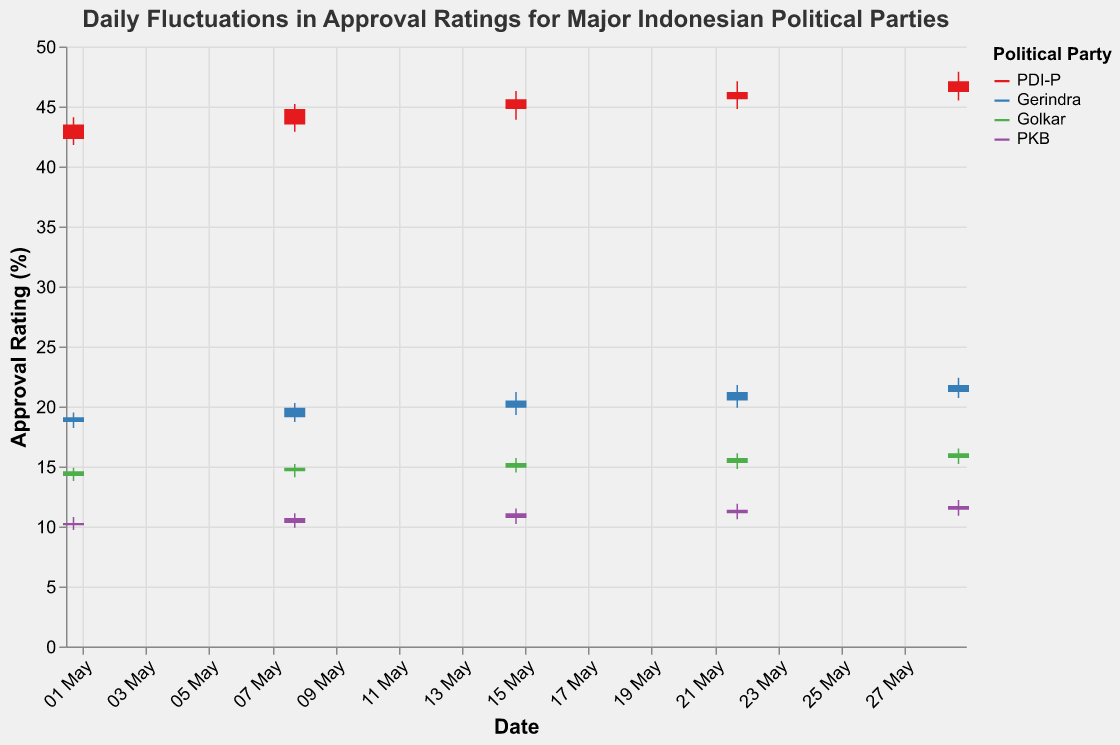What is the overall trend in the approval rating for PDI-P throughout May? The approval rating for PDI-P shows a consistent upward trend throughout May. Starting at 43.5% on May 1st, it increases weekly, ending at 47.1% on May 29th.
Answer: Upward trend How many political parties are represented in the chart? There are four political parties represented in the chart: PDI-P, Gerindra, Golkar, and PKB.
Answer: Four Which party had the highest approval rating on May 22nd? On May 22nd, PDI-P had the highest approval rating with a closing value of 46.2%.
Answer: PDI-P What was the lowest recorded approval rating for PKB in May? The lowest recorded approval rating for PKB in May was 9.7% on May 1st.
Answer: 9.7% Did any party experience a decrease in their approval rating from May 1st to May 29th? No, all parties experienced increases in their approval ratings from May 1st to May 29th.
Answer: No What is the difference between the highest and lowest approval ratings for Gerindra on May 29th? Gerindra's highest rating on May 29th was 22.4%, and the lowest was 20.7%. The difference is 22.4% - 20.7% = 1.7%.
Answer: 1.7% Which party showed the most fluctuation in their approval rating on May 15th? On May 15th, Gerindra showed the most fluctuation, with a high of 21.2% and a low of 19.3%, a difference of 21.2% - 19.3% = 1.9%.
Answer: Gerindra What was the closing approval rating for Golkar on May 8th, and how does it compare to its opening rating on May 1st? Golkar's closing rating on May 8th was 14.9%, while its opening rating on May 1st was 14.2%. It increased by 14.9% - 14.2% = 0.7%.
Answer: Increased by 0.7% How did PKB's approval rating change from May 22nd to May 29th? PKB's approval rating increased from a closing value of 11.4% on May 22nd to 11.7% on May 29th, a change of 11.7% - 11.4% = 0.3%.
Answer: Increased by 0.3% Which party had the smallest change in approval rating between consecutive weeks in May? Golkar had the smallest change between consecutive weeks from May 1st to May 8th, with an increase from 14.6% to 14.9%, a change of 0.3%.
Answer: Golkar 